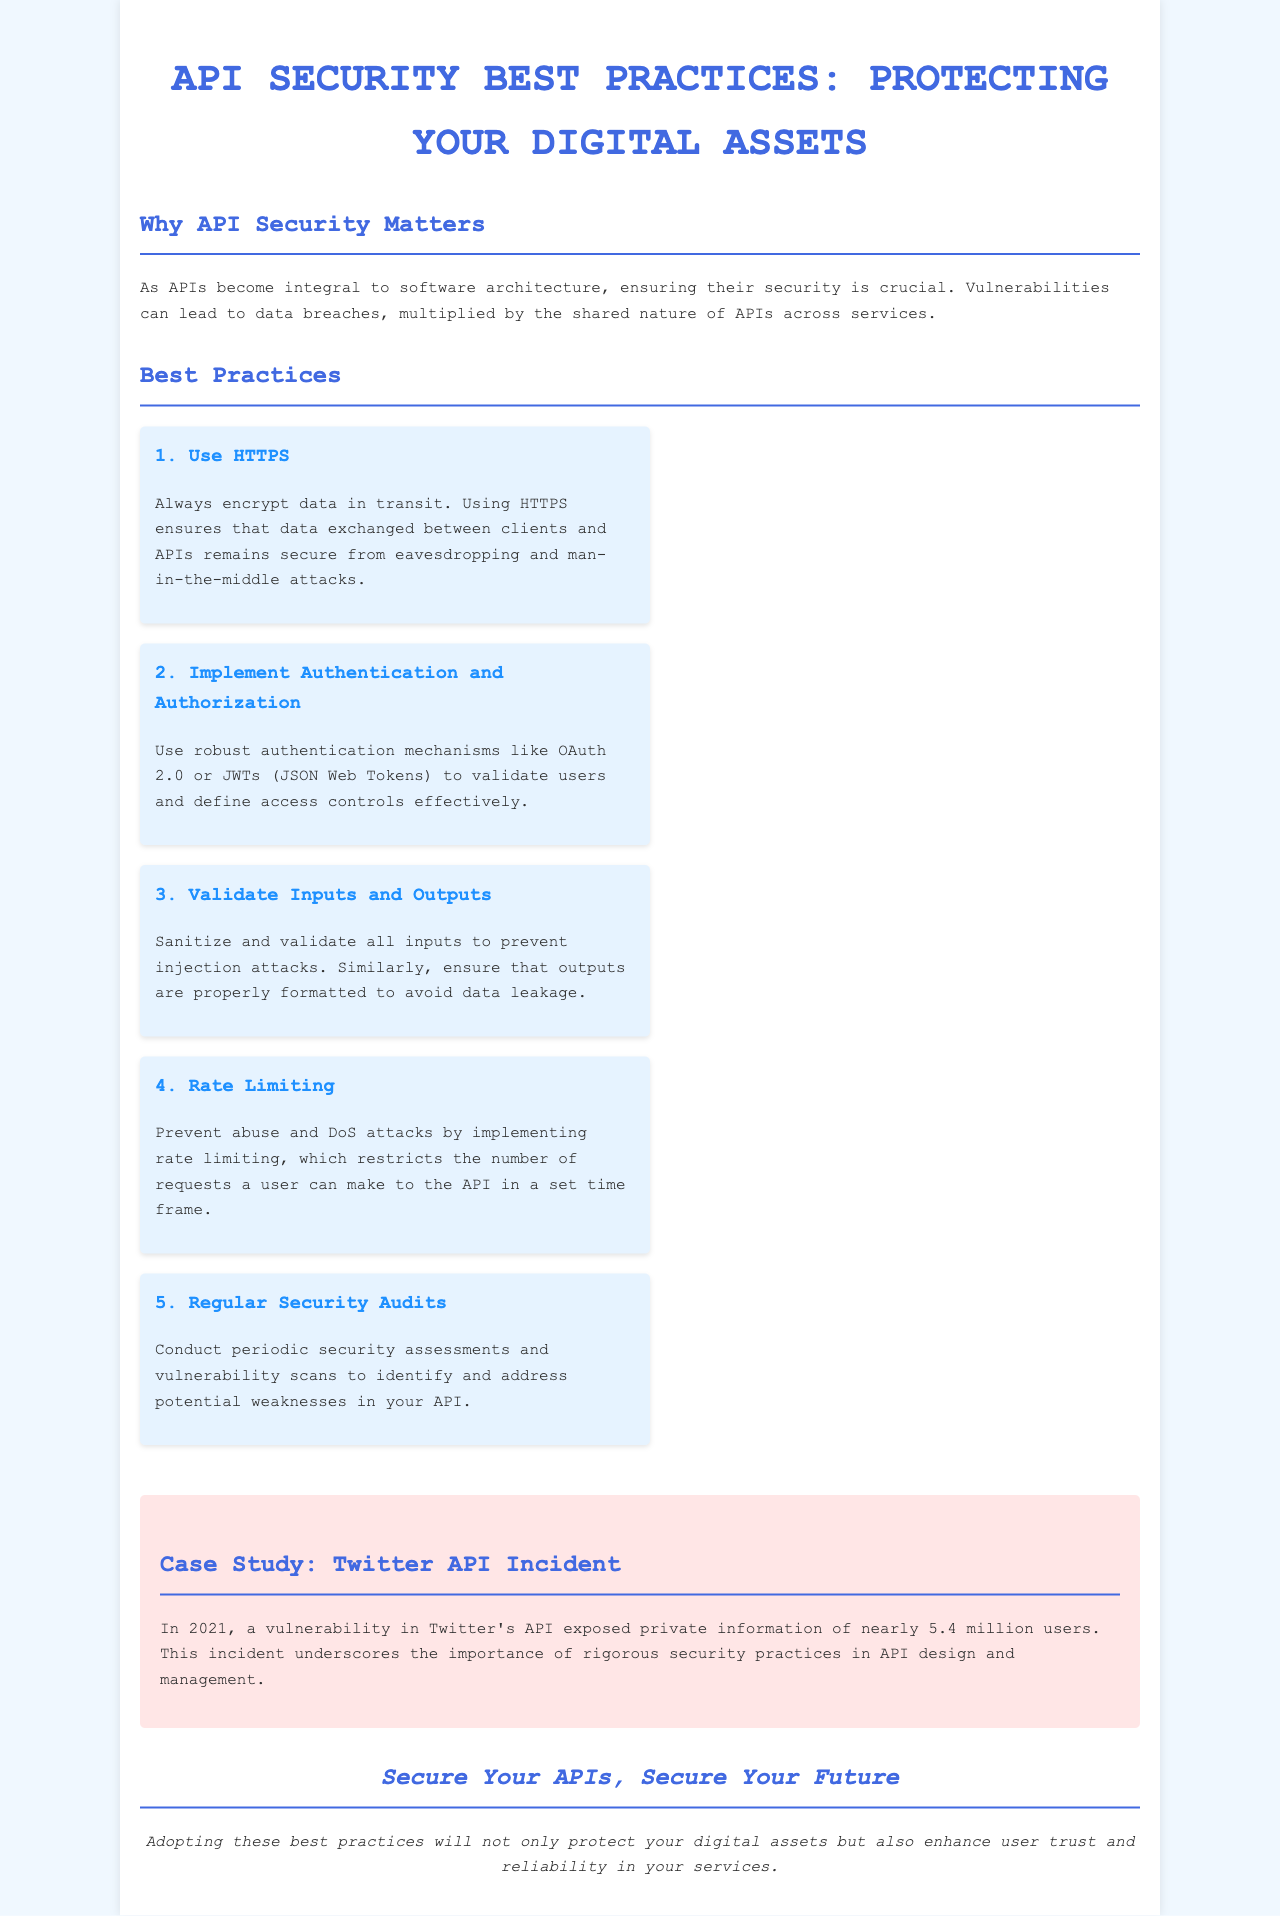What is the title of the brochure? The title is clearly stated at the top of the document.
Answer: API Security Best Practices: Protecting Your Digital Assets How many best practices are listed? A count of the practices can be found in the "Best Practices" section.
Answer: 5 What protocol should be used according to the first best practice? The first best practice explicitly mentions the protocol for secure data exchange.
Answer: HTTPS What year did the Twitter API incident occur? The case study section contains a specific year related to the incident.
Answer: 2021 What is the main purpose of implementing rate limiting? The document explains the purpose of rate limiting in the context of API security.
Answer: Prevent abuse and DoS attacks What authentication mechanisms are recommended? The second best practice specifies the authentication mechanisms to be used.
Answer: OAuth 2.0 or JWTs What color is the background of the container? The styling section indicates the color of the container background.
Answer: White What is the main takeaway from the conclusion? The conclusion summarizes the key message regarding API security.
Answer: Secure Your APIs, Secure Your Future 